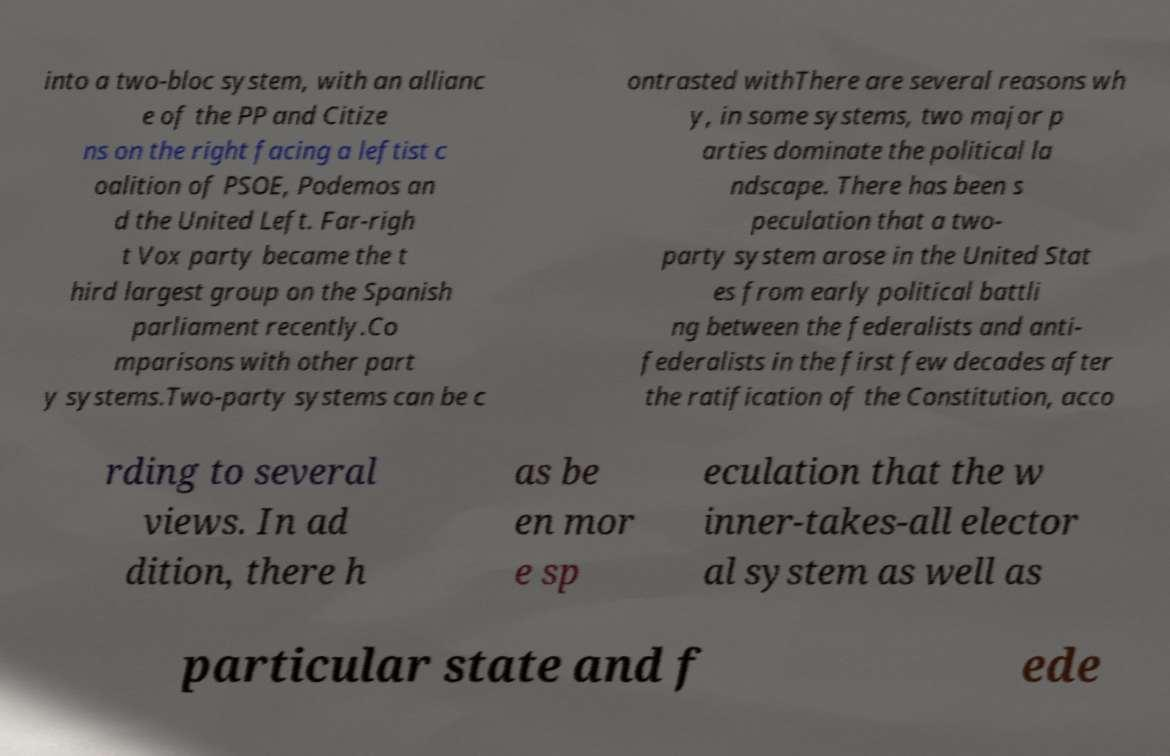What messages or text are displayed in this image? I need them in a readable, typed format. into a two-bloc system, with an allianc e of the PP and Citize ns on the right facing a leftist c oalition of PSOE, Podemos an d the United Left. Far-righ t Vox party became the t hird largest group on the Spanish parliament recently.Co mparisons with other part y systems.Two-party systems can be c ontrasted withThere are several reasons wh y, in some systems, two major p arties dominate the political la ndscape. There has been s peculation that a two- party system arose in the United Stat es from early political battli ng between the federalists and anti- federalists in the first few decades after the ratification of the Constitution, acco rding to several views. In ad dition, there h as be en mor e sp eculation that the w inner-takes-all elector al system as well as particular state and f ede 